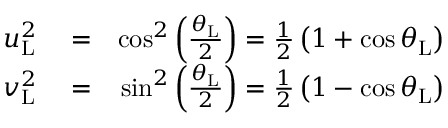Convert formula to latex. <formula><loc_0><loc_0><loc_500><loc_500>\begin{array} { r l r } { u _ { L } ^ { 2 } } & = } & { \cos ^ { 2 } \left ( \frac { \theta _ { L } } { 2 } \right ) = \frac { 1 } { 2 } \left ( 1 + \cos \theta _ { L } \right ) } \\ { v _ { L } ^ { 2 } } & = } & { \sin ^ { 2 } \left ( \frac { \theta _ { L } } { 2 } \right ) = \frac { 1 } { 2 } \left ( 1 - \cos \theta _ { L } \right ) } \end{array}</formula> 